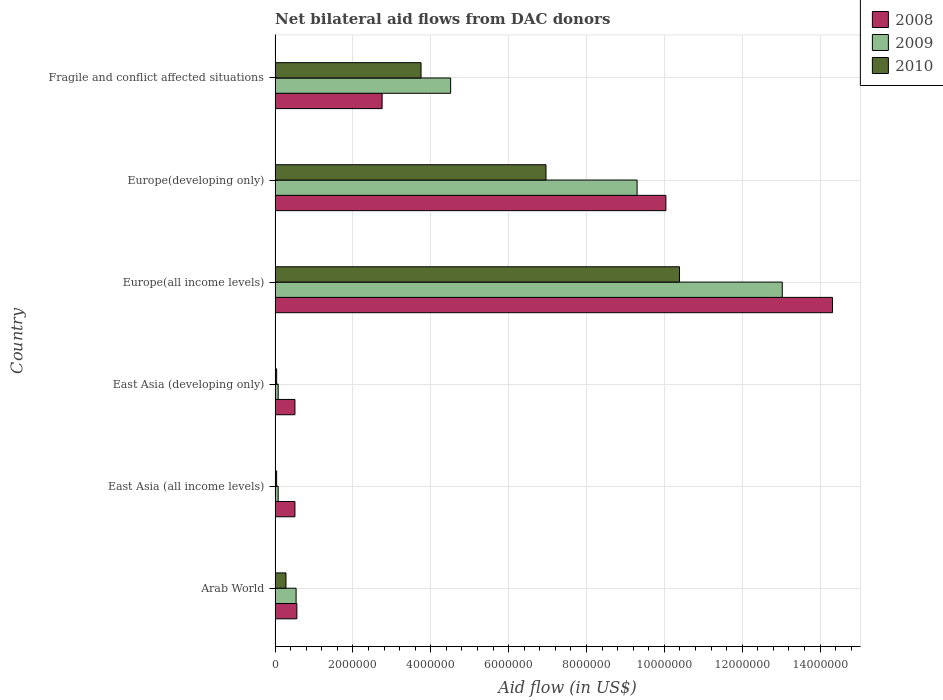How many groups of bars are there?
Keep it short and to the point. 6. How many bars are there on the 1st tick from the top?
Offer a very short reply. 3. What is the label of the 2nd group of bars from the top?
Your answer should be compact. Europe(developing only). In how many cases, is the number of bars for a given country not equal to the number of legend labels?
Give a very brief answer. 0. What is the net bilateral aid flow in 2010 in East Asia (developing only)?
Keep it short and to the point. 4.00e+04. Across all countries, what is the maximum net bilateral aid flow in 2009?
Your answer should be compact. 1.30e+07. In which country was the net bilateral aid flow in 2010 maximum?
Your answer should be very brief. Europe(all income levels). In which country was the net bilateral aid flow in 2010 minimum?
Provide a succinct answer. East Asia (all income levels). What is the total net bilateral aid flow in 2008 in the graph?
Your response must be concise. 2.87e+07. What is the difference between the net bilateral aid flow in 2008 in Arab World and that in Europe(all income levels)?
Ensure brevity in your answer.  -1.38e+07. What is the difference between the net bilateral aid flow in 2008 in Europe(developing only) and the net bilateral aid flow in 2010 in Europe(all income levels)?
Give a very brief answer. -3.50e+05. What is the average net bilateral aid flow in 2009 per country?
Offer a terse response. 4.59e+06. What is the difference between the net bilateral aid flow in 2008 and net bilateral aid flow in 2009 in Europe(developing only)?
Offer a terse response. 7.40e+05. In how many countries, is the net bilateral aid flow in 2009 greater than 7200000 US$?
Keep it short and to the point. 2. What is the ratio of the net bilateral aid flow in 2010 in Europe(developing only) to that in Fragile and conflict affected situations?
Your answer should be very brief. 1.86. What is the difference between the highest and the second highest net bilateral aid flow in 2010?
Your response must be concise. 3.43e+06. What is the difference between the highest and the lowest net bilateral aid flow in 2009?
Ensure brevity in your answer.  1.30e+07. In how many countries, is the net bilateral aid flow in 2008 greater than the average net bilateral aid flow in 2008 taken over all countries?
Provide a succinct answer. 2. Is the sum of the net bilateral aid flow in 2009 in East Asia (all income levels) and Fragile and conflict affected situations greater than the maximum net bilateral aid flow in 2010 across all countries?
Keep it short and to the point. No. What does the 1st bar from the bottom in Arab World represents?
Make the answer very short. 2008. Are all the bars in the graph horizontal?
Your answer should be compact. Yes. How many countries are there in the graph?
Offer a terse response. 6. Are the values on the major ticks of X-axis written in scientific E-notation?
Your answer should be compact. No. Does the graph contain any zero values?
Give a very brief answer. No. Does the graph contain grids?
Keep it short and to the point. Yes. How many legend labels are there?
Your answer should be compact. 3. How are the legend labels stacked?
Your response must be concise. Vertical. What is the title of the graph?
Ensure brevity in your answer.  Net bilateral aid flows from DAC donors. Does "2015" appear as one of the legend labels in the graph?
Keep it short and to the point. No. What is the label or title of the X-axis?
Make the answer very short. Aid flow (in US$). What is the label or title of the Y-axis?
Give a very brief answer. Country. What is the Aid flow (in US$) in 2008 in Arab World?
Your response must be concise. 5.60e+05. What is the Aid flow (in US$) of 2009 in Arab World?
Provide a short and direct response. 5.40e+05. What is the Aid flow (in US$) of 2008 in East Asia (all income levels)?
Provide a short and direct response. 5.10e+05. What is the Aid flow (in US$) in 2009 in East Asia (all income levels)?
Offer a terse response. 8.00e+04. What is the Aid flow (in US$) in 2010 in East Asia (all income levels)?
Give a very brief answer. 4.00e+04. What is the Aid flow (in US$) of 2008 in East Asia (developing only)?
Give a very brief answer. 5.10e+05. What is the Aid flow (in US$) in 2008 in Europe(all income levels)?
Provide a short and direct response. 1.43e+07. What is the Aid flow (in US$) in 2009 in Europe(all income levels)?
Ensure brevity in your answer.  1.30e+07. What is the Aid flow (in US$) of 2010 in Europe(all income levels)?
Your response must be concise. 1.04e+07. What is the Aid flow (in US$) in 2008 in Europe(developing only)?
Your answer should be compact. 1.00e+07. What is the Aid flow (in US$) in 2009 in Europe(developing only)?
Make the answer very short. 9.30e+06. What is the Aid flow (in US$) in 2010 in Europe(developing only)?
Offer a very short reply. 6.96e+06. What is the Aid flow (in US$) of 2008 in Fragile and conflict affected situations?
Your response must be concise. 2.75e+06. What is the Aid flow (in US$) in 2009 in Fragile and conflict affected situations?
Ensure brevity in your answer.  4.51e+06. What is the Aid flow (in US$) of 2010 in Fragile and conflict affected situations?
Your response must be concise. 3.75e+06. Across all countries, what is the maximum Aid flow (in US$) of 2008?
Ensure brevity in your answer.  1.43e+07. Across all countries, what is the maximum Aid flow (in US$) of 2009?
Your response must be concise. 1.30e+07. Across all countries, what is the maximum Aid flow (in US$) of 2010?
Keep it short and to the point. 1.04e+07. Across all countries, what is the minimum Aid flow (in US$) in 2008?
Provide a short and direct response. 5.10e+05. Across all countries, what is the minimum Aid flow (in US$) of 2009?
Provide a short and direct response. 8.00e+04. Across all countries, what is the minimum Aid flow (in US$) of 2010?
Offer a very short reply. 4.00e+04. What is the total Aid flow (in US$) of 2008 in the graph?
Your answer should be compact. 2.87e+07. What is the total Aid flow (in US$) in 2009 in the graph?
Ensure brevity in your answer.  2.75e+07. What is the total Aid flow (in US$) in 2010 in the graph?
Your answer should be compact. 2.15e+07. What is the difference between the Aid flow (in US$) in 2008 in Arab World and that in East Asia (all income levels)?
Ensure brevity in your answer.  5.00e+04. What is the difference between the Aid flow (in US$) of 2009 in Arab World and that in East Asia (all income levels)?
Ensure brevity in your answer.  4.60e+05. What is the difference between the Aid flow (in US$) in 2008 in Arab World and that in East Asia (developing only)?
Offer a terse response. 5.00e+04. What is the difference between the Aid flow (in US$) in 2008 in Arab World and that in Europe(all income levels)?
Give a very brief answer. -1.38e+07. What is the difference between the Aid flow (in US$) of 2009 in Arab World and that in Europe(all income levels)?
Make the answer very short. -1.25e+07. What is the difference between the Aid flow (in US$) in 2010 in Arab World and that in Europe(all income levels)?
Ensure brevity in your answer.  -1.01e+07. What is the difference between the Aid flow (in US$) of 2008 in Arab World and that in Europe(developing only)?
Give a very brief answer. -9.48e+06. What is the difference between the Aid flow (in US$) in 2009 in Arab World and that in Europe(developing only)?
Make the answer very short. -8.76e+06. What is the difference between the Aid flow (in US$) of 2010 in Arab World and that in Europe(developing only)?
Your answer should be compact. -6.68e+06. What is the difference between the Aid flow (in US$) in 2008 in Arab World and that in Fragile and conflict affected situations?
Provide a short and direct response. -2.19e+06. What is the difference between the Aid flow (in US$) in 2009 in Arab World and that in Fragile and conflict affected situations?
Keep it short and to the point. -3.97e+06. What is the difference between the Aid flow (in US$) in 2010 in Arab World and that in Fragile and conflict affected situations?
Ensure brevity in your answer.  -3.47e+06. What is the difference between the Aid flow (in US$) in 2008 in East Asia (all income levels) and that in Europe(all income levels)?
Offer a very short reply. -1.38e+07. What is the difference between the Aid flow (in US$) of 2009 in East Asia (all income levels) and that in Europe(all income levels)?
Your answer should be compact. -1.30e+07. What is the difference between the Aid flow (in US$) of 2010 in East Asia (all income levels) and that in Europe(all income levels)?
Provide a short and direct response. -1.04e+07. What is the difference between the Aid flow (in US$) in 2008 in East Asia (all income levels) and that in Europe(developing only)?
Provide a short and direct response. -9.53e+06. What is the difference between the Aid flow (in US$) of 2009 in East Asia (all income levels) and that in Europe(developing only)?
Make the answer very short. -9.22e+06. What is the difference between the Aid flow (in US$) of 2010 in East Asia (all income levels) and that in Europe(developing only)?
Offer a terse response. -6.92e+06. What is the difference between the Aid flow (in US$) of 2008 in East Asia (all income levels) and that in Fragile and conflict affected situations?
Ensure brevity in your answer.  -2.24e+06. What is the difference between the Aid flow (in US$) of 2009 in East Asia (all income levels) and that in Fragile and conflict affected situations?
Provide a succinct answer. -4.43e+06. What is the difference between the Aid flow (in US$) of 2010 in East Asia (all income levels) and that in Fragile and conflict affected situations?
Make the answer very short. -3.71e+06. What is the difference between the Aid flow (in US$) of 2008 in East Asia (developing only) and that in Europe(all income levels)?
Provide a short and direct response. -1.38e+07. What is the difference between the Aid flow (in US$) of 2009 in East Asia (developing only) and that in Europe(all income levels)?
Offer a terse response. -1.30e+07. What is the difference between the Aid flow (in US$) of 2010 in East Asia (developing only) and that in Europe(all income levels)?
Your answer should be compact. -1.04e+07. What is the difference between the Aid flow (in US$) of 2008 in East Asia (developing only) and that in Europe(developing only)?
Make the answer very short. -9.53e+06. What is the difference between the Aid flow (in US$) of 2009 in East Asia (developing only) and that in Europe(developing only)?
Offer a terse response. -9.22e+06. What is the difference between the Aid flow (in US$) of 2010 in East Asia (developing only) and that in Europe(developing only)?
Offer a very short reply. -6.92e+06. What is the difference between the Aid flow (in US$) in 2008 in East Asia (developing only) and that in Fragile and conflict affected situations?
Your response must be concise. -2.24e+06. What is the difference between the Aid flow (in US$) in 2009 in East Asia (developing only) and that in Fragile and conflict affected situations?
Offer a very short reply. -4.43e+06. What is the difference between the Aid flow (in US$) in 2010 in East Asia (developing only) and that in Fragile and conflict affected situations?
Your response must be concise. -3.71e+06. What is the difference between the Aid flow (in US$) of 2008 in Europe(all income levels) and that in Europe(developing only)?
Provide a short and direct response. 4.28e+06. What is the difference between the Aid flow (in US$) of 2009 in Europe(all income levels) and that in Europe(developing only)?
Ensure brevity in your answer.  3.73e+06. What is the difference between the Aid flow (in US$) in 2010 in Europe(all income levels) and that in Europe(developing only)?
Provide a succinct answer. 3.43e+06. What is the difference between the Aid flow (in US$) of 2008 in Europe(all income levels) and that in Fragile and conflict affected situations?
Your answer should be very brief. 1.16e+07. What is the difference between the Aid flow (in US$) in 2009 in Europe(all income levels) and that in Fragile and conflict affected situations?
Your response must be concise. 8.52e+06. What is the difference between the Aid flow (in US$) of 2010 in Europe(all income levels) and that in Fragile and conflict affected situations?
Give a very brief answer. 6.64e+06. What is the difference between the Aid flow (in US$) in 2008 in Europe(developing only) and that in Fragile and conflict affected situations?
Your response must be concise. 7.29e+06. What is the difference between the Aid flow (in US$) of 2009 in Europe(developing only) and that in Fragile and conflict affected situations?
Offer a terse response. 4.79e+06. What is the difference between the Aid flow (in US$) of 2010 in Europe(developing only) and that in Fragile and conflict affected situations?
Provide a short and direct response. 3.21e+06. What is the difference between the Aid flow (in US$) in 2008 in Arab World and the Aid flow (in US$) in 2009 in East Asia (all income levels)?
Provide a succinct answer. 4.80e+05. What is the difference between the Aid flow (in US$) in 2008 in Arab World and the Aid flow (in US$) in 2010 in East Asia (all income levels)?
Your answer should be compact. 5.20e+05. What is the difference between the Aid flow (in US$) in 2008 in Arab World and the Aid flow (in US$) in 2010 in East Asia (developing only)?
Your answer should be compact. 5.20e+05. What is the difference between the Aid flow (in US$) of 2008 in Arab World and the Aid flow (in US$) of 2009 in Europe(all income levels)?
Provide a short and direct response. -1.25e+07. What is the difference between the Aid flow (in US$) of 2008 in Arab World and the Aid flow (in US$) of 2010 in Europe(all income levels)?
Offer a terse response. -9.83e+06. What is the difference between the Aid flow (in US$) in 2009 in Arab World and the Aid flow (in US$) in 2010 in Europe(all income levels)?
Ensure brevity in your answer.  -9.85e+06. What is the difference between the Aid flow (in US$) of 2008 in Arab World and the Aid flow (in US$) of 2009 in Europe(developing only)?
Make the answer very short. -8.74e+06. What is the difference between the Aid flow (in US$) in 2008 in Arab World and the Aid flow (in US$) in 2010 in Europe(developing only)?
Keep it short and to the point. -6.40e+06. What is the difference between the Aid flow (in US$) of 2009 in Arab World and the Aid flow (in US$) of 2010 in Europe(developing only)?
Your answer should be compact. -6.42e+06. What is the difference between the Aid flow (in US$) of 2008 in Arab World and the Aid flow (in US$) of 2009 in Fragile and conflict affected situations?
Offer a very short reply. -3.95e+06. What is the difference between the Aid flow (in US$) of 2008 in Arab World and the Aid flow (in US$) of 2010 in Fragile and conflict affected situations?
Offer a terse response. -3.19e+06. What is the difference between the Aid flow (in US$) of 2009 in Arab World and the Aid flow (in US$) of 2010 in Fragile and conflict affected situations?
Your answer should be very brief. -3.21e+06. What is the difference between the Aid flow (in US$) in 2009 in East Asia (all income levels) and the Aid flow (in US$) in 2010 in East Asia (developing only)?
Make the answer very short. 4.00e+04. What is the difference between the Aid flow (in US$) in 2008 in East Asia (all income levels) and the Aid flow (in US$) in 2009 in Europe(all income levels)?
Offer a very short reply. -1.25e+07. What is the difference between the Aid flow (in US$) in 2008 in East Asia (all income levels) and the Aid flow (in US$) in 2010 in Europe(all income levels)?
Your response must be concise. -9.88e+06. What is the difference between the Aid flow (in US$) in 2009 in East Asia (all income levels) and the Aid flow (in US$) in 2010 in Europe(all income levels)?
Keep it short and to the point. -1.03e+07. What is the difference between the Aid flow (in US$) in 2008 in East Asia (all income levels) and the Aid flow (in US$) in 2009 in Europe(developing only)?
Provide a short and direct response. -8.79e+06. What is the difference between the Aid flow (in US$) of 2008 in East Asia (all income levels) and the Aid flow (in US$) of 2010 in Europe(developing only)?
Give a very brief answer. -6.45e+06. What is the difference between the Aid flow (in US$) in 2009 in East Asia (all income levels) and the Aid flow (in US$) in 2010 in Europe(developing only)?
Offer a very short reply. -6.88e+06. What is the difference between the Aid flow (in US$) of 2008 in East Asia (all income levels) and the Aid flow (in US$) of 2009 in Fragile and conflict affected situations?
Offer a very short reply. -4.00e+06. What is the difference between the Aid flow (in US$) of 2008 in East Asia (all income levels) and the Aid flow (in US$) of 2010 in Fragile and conflict affected situations?
Give a very brief answer. -3.24e+06. What is the difference between the Aid flow (in US$) in 2009 in East Asia (all income levels) and the Aid flow (in US$) in 2010 in Fragile and conflict affected situations?
Offer a terse response. -3.67e+06. What is the difference between the Aid flow (in US$) of 2008 in East Asia (developing only) and the Aid flow (in US$) of 2009 in Europe(all income levels)?
Provide a short and direct response. -1.25e+07. What is the difference between the Aid flow (in US$) in 2008 in East Asia (developing only) and the Aid flow (in US$) in 2010 in Europe(all income levels)?
Offer a terse response. -9.88e+06. What is the difference between the Aid flow (in US$) of 2009 in East Asia (developing only) and the Aid flow (in US$) of 2010 in Europe(all income levels)?
Your answer should be compact. -1.03e+07. What is the difference between the Aid flow (in US$) in 2008 in East Asia (developing only) and the Aid flow (in US$) in 2009 in Europe(developing only)?
Make the answer very short. -8.79e+06. What is the difference between the Aid flow (in US$) in 2008 in East Asia (developing only) and the Aid flow (in US$) in 2010 in Europe(developing only)?
Your answer should be very brief. -6.45e+06. What is the difference between the Aid flow (in US$) of 2009 in East Asia (developing only) and the Aid flow (in US$) of 2010 in Europe(developing only)?
Your response must be concise. -6.88e+06. What is the difference between the Aid flow (in US$) in 2008 in East Asia (developing only) and the Aid flow (in US$) in 2010 in Fragile and conflict affected situations?
Offer a terse response. -3.24e+06. What is the difference between the Aid flow (in US$) of 2009 in East Asia (developing only) and the Aid flow (in US$) of 2010 in Fragile and conflict affected situations?
Offer a terse response. -3.67e+06. What is the difference between the Aid flow (in US$) in 2008 in Europe(all income levels) and the Aid flow (in US$) in 2009 in Europe(developing only)?
Give a very brief answer. 5.02e+06. What is the difference between the Aid flow (in US$) in 2008 in Europe(all income levels) and the Aid flow (in US$) in 2010 in Europe(developing only)?
Provide a short and direct response. 7.36e+06. What is the difference between the Aid flow (in US$) in 2009 in Europe(all income levels) and the Aid flow (in US$) in 2010 in Europe(developing only)?
Your response must be concise. 6.07e+06. What is the difference between the Aid flow (in US$) of 2008 in Europe(all income levels) and the Aid flow (in US$) of 2009 in Fragile and conflict affected situations?
Provide a succinct answer. 9.81e+06. What is the difference between the Aid flow (in US$) of 2008 in Europe(all income levels) and the Aid flow (in US$) of 2010 in Fragile and conflict affected situations?
Keep it short and to the point. 1.06e+07. What is the difference between the Aid flow (in US$) in 2009 in Europe(all income levels) and the Aid flow (in US$) in 2010 in Fragile and conflict affected situations?
Keep it short and to the point. 9.28e+06. What is the difference between the Aid flow (in US$) in 2008 in Europe(developing only) and the Aid flow (in US$) in 2009 in Fragile and conflict affected situations?
Your answer should be very brief. 5.53e+06. What is the difference between the Aid flow (in US$) of 2008 in Europe(developing only) and the Aid flow (in US$) of 2010 in Fragile and conflict affected situations?
Provide a short and direct response. 6.29e+06. What is the difference between the Aid flow (in US$) in 2009 in Europe(developing only) and the Aid flow (in US$) in 2010 in Fragile and conflict affected situations?
Offer a terse response. 5.55e+06. What is the average Aid flow (in US$) of 2008 per country?
Provide a succinct answer. 4.78e+06. What is the average Aid flow (in US$) in 2009 per country?
Your answer should be very brief. 4.59e+06. What is the average Aid flow (in US$) of 2010 per country?
Ensure brevity in your answer.  3.58e+06. What is the difference between the Aid flow (in US$) of 2009 and Aid flow (in US$) of 2010 in Arab World?
Your answer should be very brief. 2.60e+05. What is the difference between the Aid flow (in US$) in 2009 and Aid flow (in US$) in 2010 in East Asia (developing only)?
Your answer should be compact. 4.00e+04. What is the difference between the Aid flow (in US$) in 2008 and Aid flow (in US$) in 2009 in Europe(all income levels)?
Keep it short and to the point. 1.29e+06. What is the difference between the Aid flow (in US$) in 2008 and Aid flow (in US$) in 2010 in Europe(all income levels)?
Offer a very short reply. 3.93e+06. What is the difference between the Aid flow (in US$) of 2009 and Aid flow (in US$) of 2010 in Europe(all income levels)?
Provide a short and direct response. 2.64e+06. What is the difference between the Aid flow (in US$) of 2008 and Aid flow (in US$) of 2009 in Europe(developing only)?
Keep it short and to the point. 7.40e+05. What is the difference between the Aid flow (in US$) in 2008 and Aid flow (in US$) in 2010 in Europe(developing only)?
Provide a succinct answer. 3.08e+06. What is the difference between the Aid flow (in US$) in 2009 and Aid flow (in US$) in 2010 in Europe(developing only)?
Your answer should be compact. 2.34e+06. What is the difference between the Aid flow (in US$) in 2008 and Aid flow (in US$) in 2009 in Fragile and conflict affected situations?
Offer a very short reply. -1.76e+06. What is the difference between the Aid flow (in US$) in 2009 and Aid flow (in US$) in 2010 in Fragile and conflict affected situations?
Your response must be concise. 7.60e+05. What is the ratio of the Aid flow (in US$) of 2008 in Arab World to that in East Asia (all income levels)?
Keep it short and to the point. 1.1. What is the ratio of the Aid flow (in US$) in 2009 in Arab World to that in East Asia (all income levels)?
Your response must be concise. 6.75. What is the ratio of the Aid flow (in US$) of 2008 in Arab World to that in East Asia (developing only)?
Offer a terse response. 1.1. What is the ratio of the Aid flow (in US$) in 2009 in Arab World to that in East Asia (developing only)?
Your answer should be compact. 6.75. What is the ratio of the Aid flow (in US$) in 2008 in Arab World to that in Europe(all income levels)?
Offer a terse response. 0.04. What is the ratio of the Aid flow (in US$) of 2009 in Arab World to that in Europe(all income levels)?
Ensure brevity in your answer.  0.04. What is the ratio of the Aid flow (in US$) in 2010 in Arab World to that in Europe(all income levels)?
Your response must be concise. 0.03. What is the ratio of the Aid flow (in US$) in 2008 in Arab World to that in Europe(developing only)?
Provide a short and direct response. 0.06. What is the ratio of the Aid flow (in US$) in 2009 in Arab World to that in Europe(developing only)?
Your answer should be compact. 0.06. What is the ratio of the Aid flow (in US$) of 2010 in Arab World to that in Europe(developing only)?
Your answer should be very brief. 0.04. What is the ratio of the Aid flow (in US$) in 2008 in Arab World to that in Fragile and conflict affected situations?
Give a very brief answer. 0.2. What is the ratio of the Aid flow (in US$) of 2009 in Arab World to that in Fragile and conflict affected situations?
Keep it short and to the point. 0.12. What is the ratio of the Aid flow (in US$) in 2010 in Arab World to that in Fragile and conflict affected situations?
Your response must be concise. 0.07. What is the ratio of the Aid flow (in US$) of 2010 in East Asia (all income levels) to that in East Asia (developing only)?
Offer a very short reply. 1. What is the ratio of the Aid flow (in US$) in 2008 in East Asia (all income levels) to that in Europe(all income levels)?
Your answer should be compact. 0.04. What is the ratio of the Aid flow (in US$) of 2009 in East Asia (all income levels) to that in Europe(all income levels)?
Your response must be concise. 0.01. What is the ratio of the Aid flow (in US$) in 2010 in East Asia (all income levels) to that in Europe(all income levels)?
Offer a very short reply. 0. What is the ratio of the Aid flow (in US$) in 2008 in East Asia (all income levels) to that in Europe(developing only)?
Your response must be concise. 0.05. What is the ratio of the Aid flow (in US$) of 2009 in East Asia (all income levels) to that in Europe(developing only)?
Make the answer very short. 0.01. What is the ratio of the Aid flow (in US$) in 2010 in East Asia (all income levels) to that in Europe(developing only)?
Make the answer very short. 0.01. What is the ratio of the Aid flow (in US$) of 2008 in East Asia (all income levels) to that in Fragile and conflict affected situations?
Offer a very short reply. 0.19. What is the ratio of the Aid flow (in US$) in 2009 in East Asia (all income levels) to that in Fragile and conflict affected situations?
Provide a succinct answer. 0.02. What is the ratio of the Aid flow (in US$) of 2010 in East Asia (all income levels) to that in Fragile and conflict affected situations?
Offer a terse response. 0.01. What is the ratio of the Aid flow (in US$) in 2008 in East Asia (developing only) to that in Europe(all income levels)?
Your answer should be compact. 0.04. What is the ratio of the Aid flow (in US$) in 2009 in East Asia (developing only) to that in Europe(all income levels)?
Offer a terse response. 0.01. What is the ratio of the Aid flow (in US$) of 2010 in East Asia (developing only) to that in Europe(all income levels)?
Ensure brevity in your answer.  0. What is the ratio of the Aid flow (in US$) in 2008 in East Asia (developing only) to that in Europe(developing only)?
Provide a short and direct response. 0.05. What is the ratio of the Aid flow (in US$) in 2009 in East Asia (developing only) to that in Europe(developing only)?
Make the answer very short. 0.01. What is the ratio of the Aid flow (in US$) of 2010 in East Asia (developing only) to that in Europe(developing only)?
Keep it short and to the point. 0.01. What is the ratio of the Aid flow (in US$) of 2008 in East Asia (developing only) to that in Fragile and conflict affected situations?
Provide a short and direct response. 0.19. What is the ratio of the Aid flow (in US$) of 2009 in East Asia (developing only) to that in Fragile and conflict affected situations?
Your response must be concise. 0.02. What is the ratio of the Aid flow (in US$) in 2010 in East Asia (developing only) to that in Fragile and conflict affected situations?
Provide a succinct answer. 0.01. What is the ratio of the Aid flow (in US$) of 2008 in Europe(all income levels) to that in Europe(developing only)?
Offer a terse response. 1.43. What is the ratio of the Aid flow (in US$) in 2009 in Europe(all income levels) to that in Europe(developing only)?
Your response must be concise. 1.4. What is the ratio of the Aid flow (in US$) in 2010 in Europe(all income levels) to that in Europe(developing only)?
Offer a terse response. 1.49. What is the ratio of the Aid flow (in US$) of 2008 in Europe(all income levels) to that in Fragile and conflict affected situations?
Ensure brevity in your answer.  5.21. What is the ratio of the Aid flow (in US$) of 2009 in Europe(all income levels) to that in Fragile and conflict affected situations?
Offer a terse response. 2.89. What is the ratio of the Aid flow (in US$) in 2010 in Europe(all income levels) to that in Fragile and conflict affected situations?
Make the answer very short. 2.77. What is the ratio of the Aid flow (in US$) of 2008 in Europe(developing only) to that in Fragile and conflict affected situations?
Ensure brevity in your answer.  3.65. What is the ratio of the Aid flow (in US$) of 2009 in Europe(developing only) to that in Fragile and conflict affected situations?
Your answer should be very brief. 2.06. What is the ratio of the Aid flow (in US$) in 2010 in Europe(developing only) to that in Fragile and conflict affected situations?
Offer a very short reply. 1.86. What is the difference between the highest and the second highest Aid flow (in US$) of 2008?
Provide a succinct answer. 4.28e+06. What is the difference between the highest and the second highest Aid flow (in US$) of 2009?
Keep it short and to the point. 3.73e+06. What is the difference between the highest and the second highest Aid flow (in US$) in 2010?
Offer a very short reply. 3.43e+06. What is the difference between the highest and the lowest Aid flow (in US$) of 2008?
Provide a succinct answer. 1.38e+07. What is the difference between the highest and the lowest Aid flow (in US$) in 2009?
Ensure brevity in your answer.  1.30e+07. What is the difference between the highest and the lowest Aid flow (in US$) of 2010?
Give a very brief answer. 1.04e+07. 